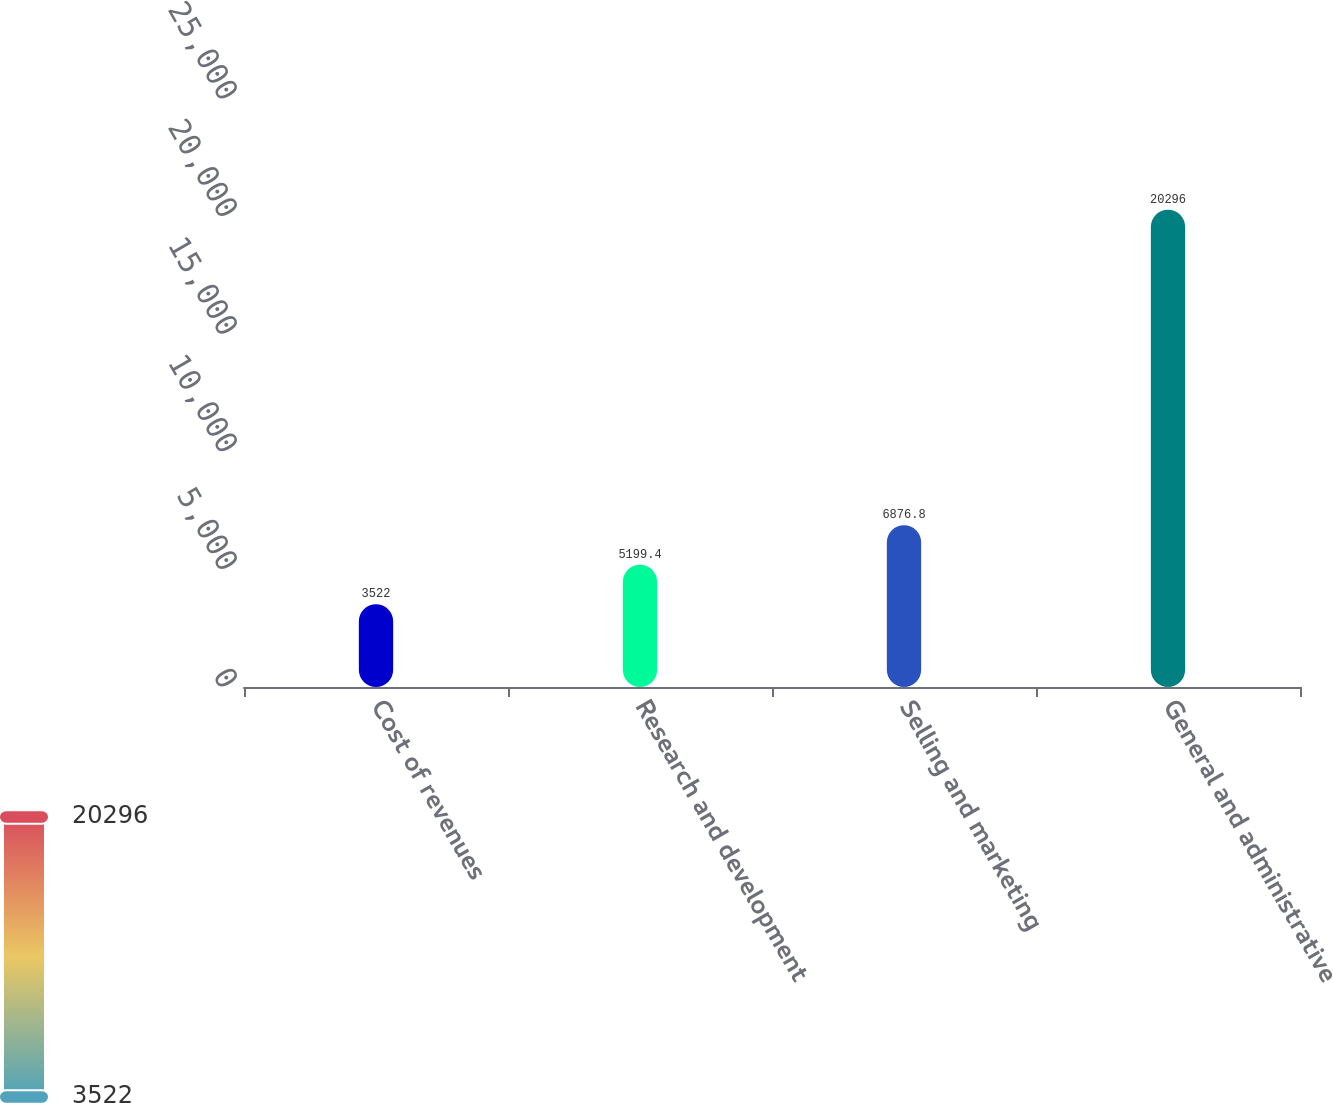<chart> <loc_0><loc_0><loc_500><loc_500><bar_chart><fcel>Cost of revenues<fcel>Research and development<fcel>Selling and marketing<fcel>General and administrative<nl><fcel>3522<fcel>5199.4<fcel>6876.8<fcel>20296<nl></chart> 